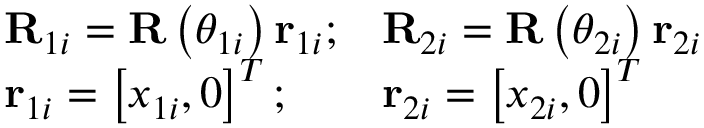<formula> <loc_0><loc_0><loc_500><loc_500>\begin{array} { r } { \begin{array} { l l l } { R _ { 1 i } = R \left ( \theta _ { 1 i } \right ) r _ { 1 i } ; } & { R _ { 2 i } = R \left ( \theta _ { 2 i } \right ) r _ { 2 i } } \\ { r _ { 1 i } = \left [ x _ { 1 i } , 0 \right ] ^ { T } ; } & { r _ { 2 i } = \left [ x _ { 2 i } , 0 \right ] ^ { T } } \end{array} } \end{array}</formula> 